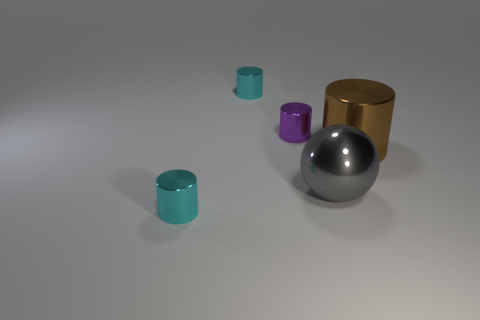Subtract all big brown metal cylinders. How many cylinders are left? 3 Subtract all gray cylinders. Subtract all gray blocks. How many cylinders are left? 4 Add 4 small things. How many objects exist? 9 Subtract all balls. How many objects are left? 4 Subtract 0 blue cylinders. How many objects are left? 5 Subtract all gray metal things. Subtract all small purple things. How many objects are left? 3 Add 4 cyan cylinders. How many cyan cylinders are left? 6 Add 2 balls. How many balls exist? 3 